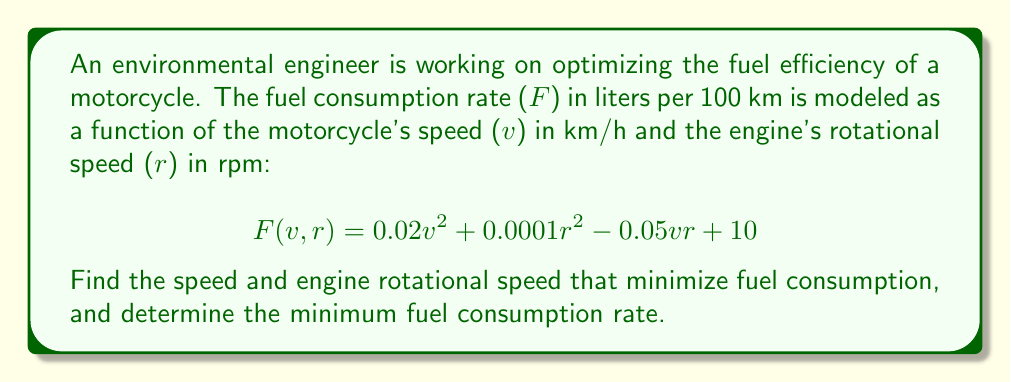Teach me how to tackle this problem. To find the minimum fuel consumption rate, we need to find the critical points of the function $F(v,r)$ and evaluate the nature of these points.

1. Find partial derivatives:
   $$\frac{\partial F}{\partial v} = 0.04v - 0.05r$$
   $$\frac{\partial F}{\partial r} = 0.0002r - 0.05v$$

2. Set both partial derivatives to zero and solve the system of equations:
   $$0.04v - 0.05r = 0$$
   $$0.0002r - 0.05v = 0$$

3. Multiply the first equation by 0.0002 and the second by 0.04:
   $$0.000008v - 0.00001r = 0$$
   $$0.000008r - 0.002v = 0$$

4. Add these equations:
   $$0.000008v + 0.000008r - 0.00001r - 0.002v = 0$$
   $$-0.001992v - 0.000002r = 0$$

5. Solve for r in terms of v:
   $$r = -996v$$

6. Substitute this into one of the original equations:
   $$0.04v - 0.05(-996v) = 0$$
   $$0.04v + 49.8v = 0$$
   $$49.84v = 0$$
   $$v = 0$$

7. Since v = 0, r must also be 0.

8. To confirm this is a minimum, we need to check the second partial derivatives:
   $$\frac{\partial^2 F}{\partial v^2} = 0.04$$
   $$\frac{\partial^2 F}{\partial r^2} = 0.0002$$
   $$\frac{\partial^2 F}{\partial v \partial r} = -0.05$$

   The Hessian matrix is:
   $$H = \begin{bmatrix} 0.04 & -0.05 \\ -0.05 & 0.0002 \end{bmatrix}$$

   The determinant of H is:
   $$\det(H) = 0.04 \cdot 0.0002 - (-0.05)^2 = -0.002492$$

   Since the determinant is negative, the critical point is a saddle point, not a minimum.

9. As the function is quadratic and opens upward in both v and r directions, the global minimum must occur at the boundary of the feasible region. In practice, this would be the lowest possible speed and engine rotation rate at which the motorcycle can operate stably.

10. Assuming a minimum practical speed of 20 km/h and a corresponding engine speed of 1000 rpm, we can calculate the minimum fuel consumption:

    $$F(20, 1000) = 0.02(20)^2 + 0.0001(1000)^2 - 0.05(20)(1000) + 10$$
    $$= 8 + 100 - 1000 + 10 = -882$$

    However, this negative value is not physically meaningful. The model is likely only valid for a certain range of speeds and engine rotations.
Answer: The mathematical minimum occurs at v = 0 km/h and r = 0 rpm, but this is not practical. The actual minimum fuel consumption would occur at the lowest practical operating speed and engine rotation rate, which depends on the specific motorcycle model and operating conditions. The given fuel consumption model may need refinement to accurately represent real-world behavior across all speed ranges. 